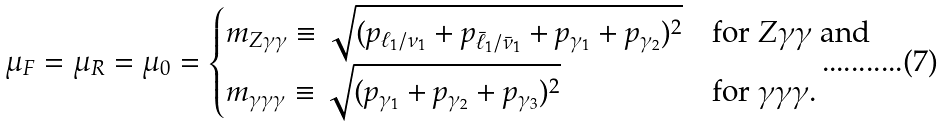Convert formula to latex. <formula><loc_0><loc_0><loc_500><loc_500>\mu _ { F } = \mu _ { R } = \mu _ { 0 } = \begin{cases} m _ { Z \gamma \gamma } \equiv \sqrt { ( p _ { \ell _ { 1 } / \nu _ { 1 } } + p _ { \bar { \ell } _ { 1 } / \bar { \nu } _ { 1 } } + p _ { \gamma _ { 1 } } + p _ { \gamma _ { 2 } } ) ^ { 2 } } & \text {for $Z\gamma\gamma$ and} \\ m _ { \gamma \gamma \gamma } \equiv \sqrt { ( p _ { \gamma _ { 1 } } + p _ { \gamma _ { 2 } } + p _ { \gamma _ { 3 } } ) ^ { 2 } } & \text {for $\gamma\gamma\gamma$.} \end{cases}</formula> 